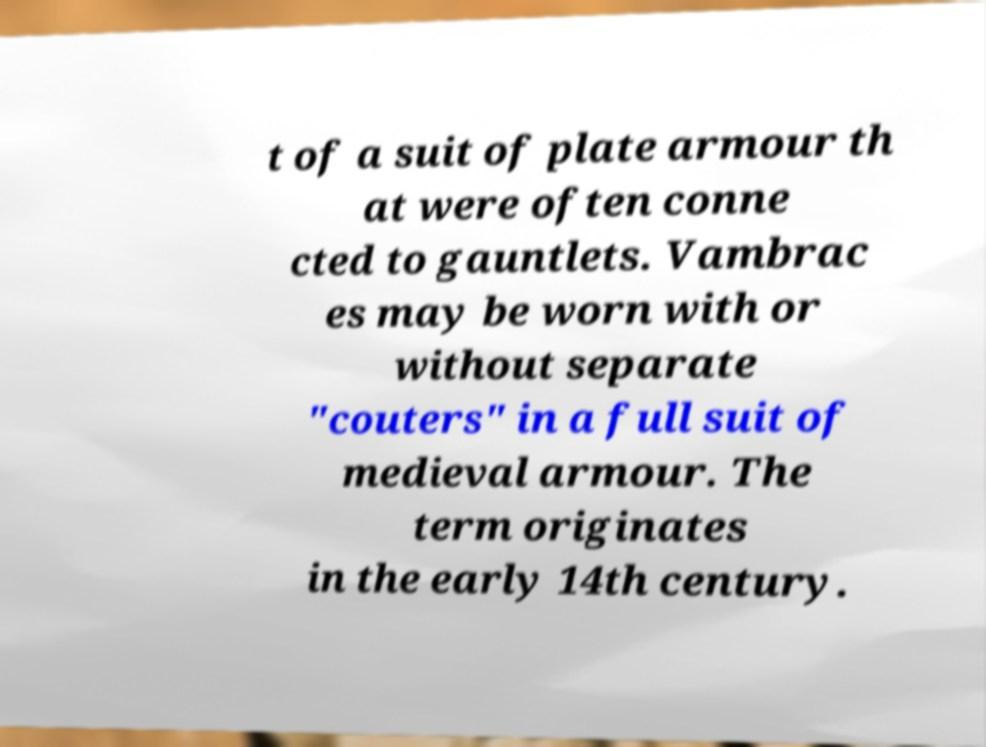Could you extract and type out the text from this image? t of a suit of plate armour th at were often conne cted to gauntlets. Vambrac es may be worn with or without separate "couters" in a full suit of medieval armour. The term originates in the early 14th century. 